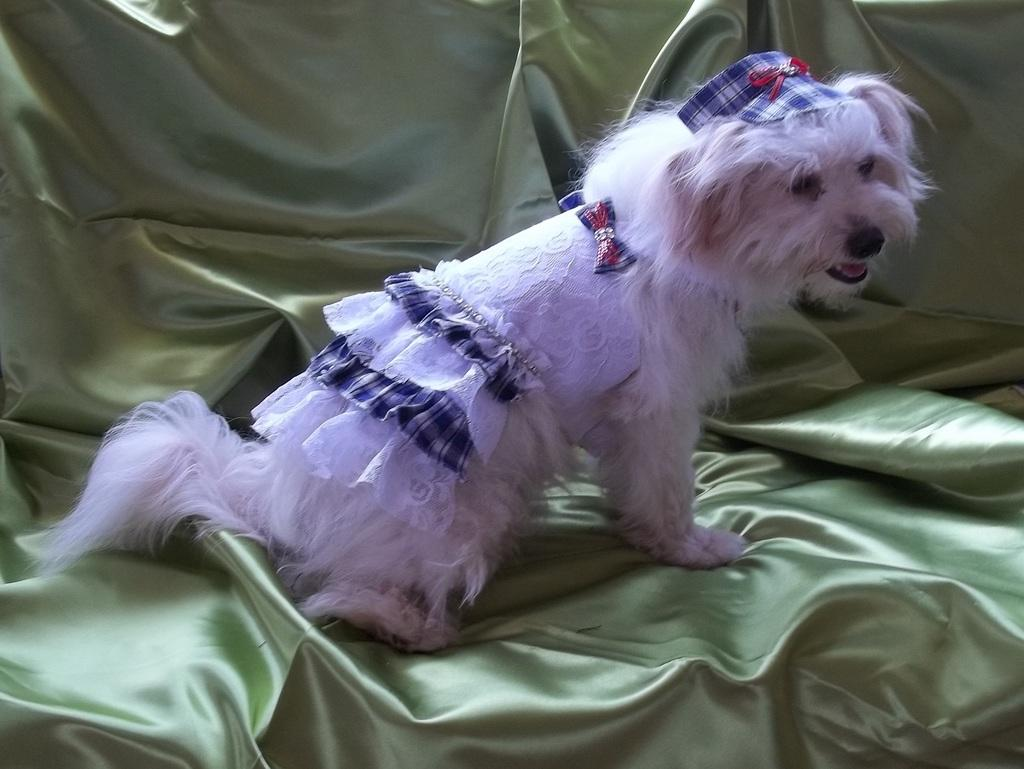What type of animal is present in the image? There is a dog in the image. What is the dog wearing in the image? The dog is wearing a costume in the image. What is the dog standing or sitting on in the image? The dog is on a cloth in the image. What type of plantation can be seen in the background of the image? There is no plantation present in the image; it features a dog wearing a costume and standing on a cloth. 